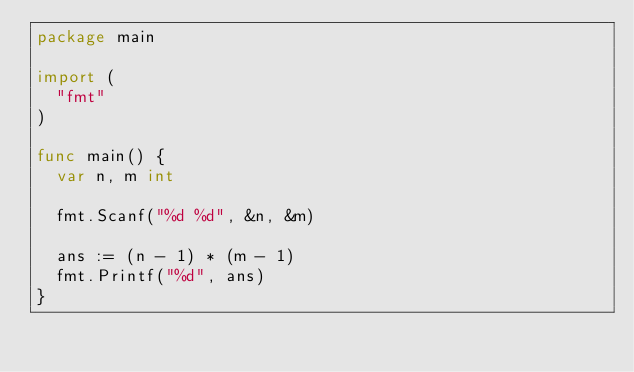<code> <loc_0><loc_0><loc_500><loc_500><_Go_>package main

import (
  "fmt"
)

func main() {
  var n, m int
  
  fmt.Scanf("%d %d", &n, &m)
  
  ans := (n - 1) * (m - 1)
  fmt.Printf("%d", ans)
}</code> 